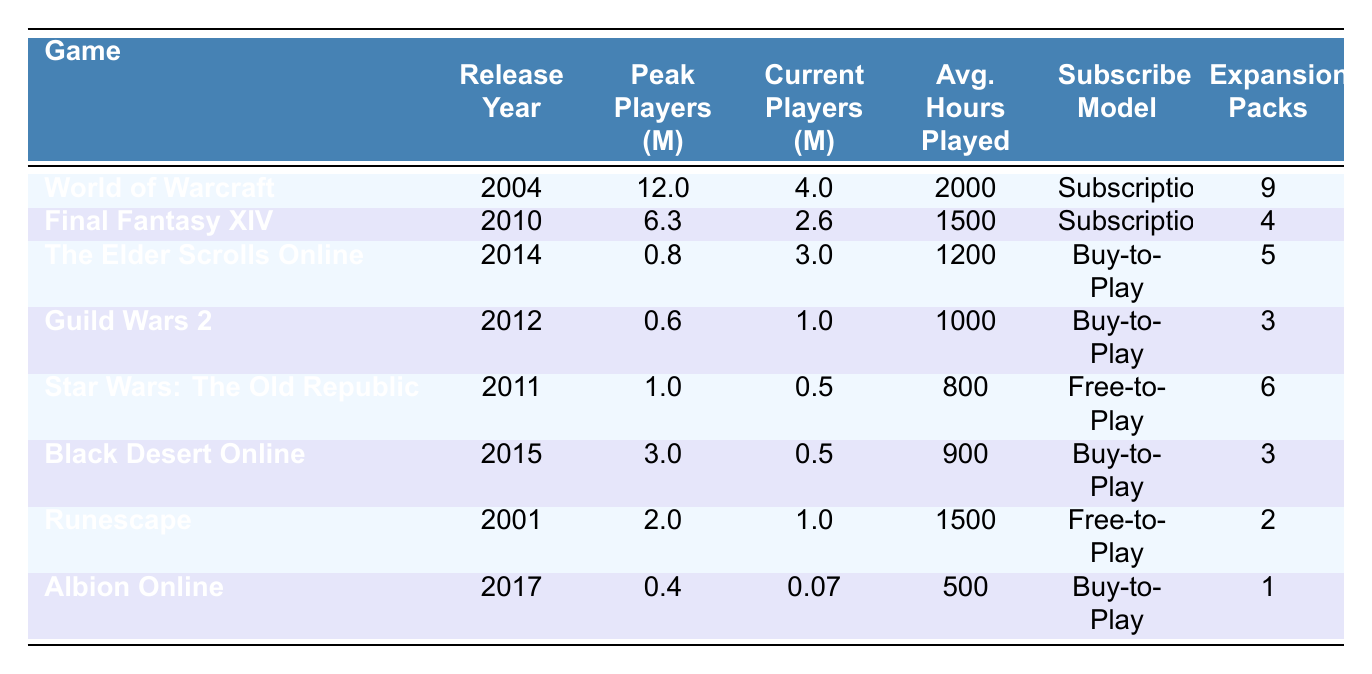What MMORPG has the highest peak players? The peak players for each game are listed in the table. World of Warcraft has the highest peak player count at 12 million.
Answer: World of Warcraft Which game has more current players: Final Fantasy XIV or The Elder Scrolls Online? Current player counts for both games are 2.6 million for Final Fantasy XIV and 3 million for The Elder Scrolls Online. Since 3 million is greater than 2.6 million, The Elder Scrolls Online has more current players.
Answer: The Elder Scrolls Online What is the average hours played for World of Warcraft and Runescape combined? The average hours played for World of Warcraft is 2000 and for Runescape is 1500. Adding these gives 2000 + 1500 = 3500. To find the average, divide by 2, resulting in 3500 / 2 = 1750.
Answer: 1750 Does Star Wars: The Old Republic have more expansion packs than Guild Wars 2? Star Wars: The Old Republic has 6 expansion packs, while Guild Wars 2 has 3. Since 6 is greater than 3, the answer is yes.
Answer: Yes Which game has the lowest average hours played? The average hours played for each game are listed. Albion Online has the lowest average hours played at 500.
Answer: Albion Online What is the difference in peak players between Black Desert Online and The Elder Scrolls Online? Black Desert Online has 3 million peak players, while The Elder Scrolls Online has 0.8 million. The difference is 3 million - 0.8 million = 2.2 million.
Answer: 2.2 million Which MMORPGs have a free-to-play subscriber model? The table lists subscriber models: Star Wars: The Old Republic and Runescape are marked as free-to-play, indicating that these two games fit the criteria.
Answer: Star Wars: The Old Republic and Runescape Is the average hours played for Final Fantasy XIV greater than 1200? The average hours played for Final Fantasy XIV is 1500, which is greater than 1200, so the answer is yes.
Answer: Yes What is the total number of current players across all games listed? To find the total, add the current players of all games: 4 million (WoW) + 2.6 million (FFXIV) + 3 million (ESO) + 1 million (GW2) + 0.5 million (SWTOR) + 0.5 million (BDO) + 1 million (Runescape) + 0.07 million (Albion) = 12.67 million.
Answer: 12.67 million 